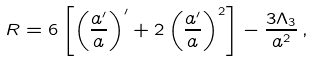<formula> <loc_0><loc_0><loc_500><loc_500>R = 6 \left [ \left ( \frac { a ^ { \prime } } { a } \right ) ^ { \prime } + 2 \left ( \frac { a ^ { \prime } } { a } \right ) ^ { 2 } \right ] - \frac { 3 \Lambda _ { 3 } } { a ^ { 2 } } \, ,</formula> 